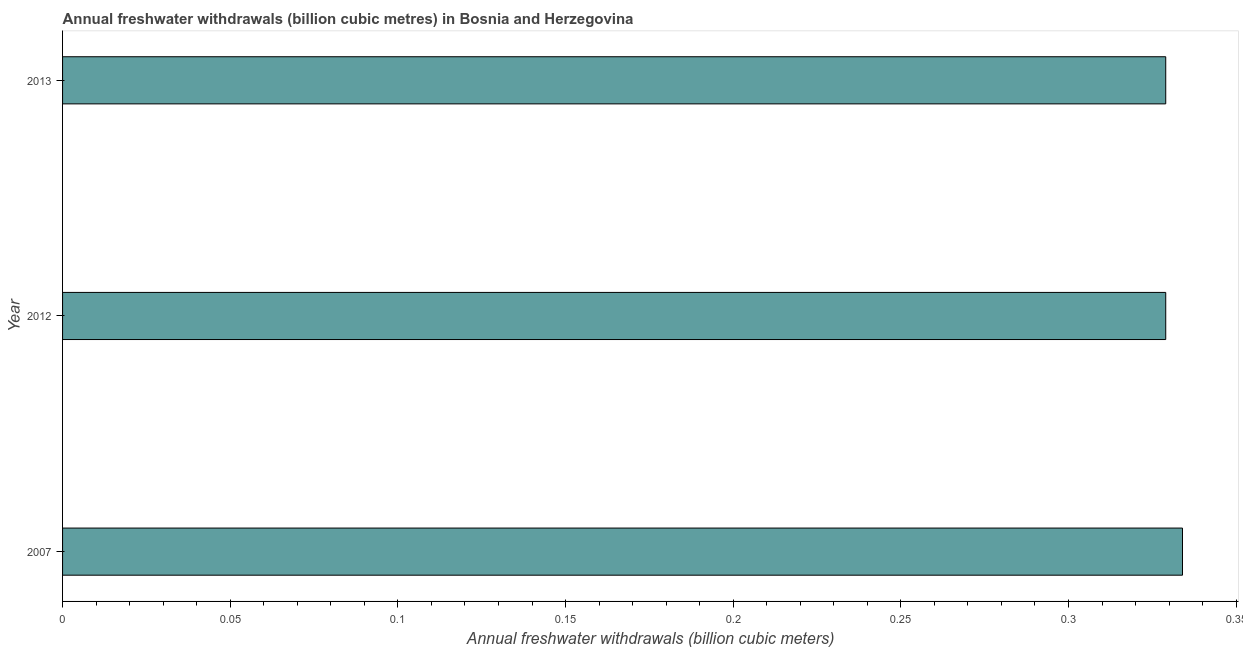What is the title of the graph?
Your answer should be compact. Annual freshwater withdrawals (billion cubic metres) in Bosnia and Herzegovina. What is the label or title of the X-axis?
Provide a short and direct response. Annual freshwater withdrawals (billion cubic meters). What is the annual freshwater withdrawals in 2012?
Your response must be concise. 0.33. Across all years, what is the maximum annual freshwater withdrawals?
Keep it short and to the point. 0.33. Across all years, what is the minimum annual freshwater withdrawals?
Make the answer very short. 0.33. In which year was the annual freshwater withdrawals maximum?
Provide a succinct answer. 2007. In which year was the annual freshwater withdrawals minimum?
Give a very brief answer. 2012. What is the difference between the annual freshwater withdrawals in 2012 and 2013?
Provide a short and direct response. 0. What is the average annual freshwater withdrawals per year?
Your answer should be compact. 0.33. What is the median annual freshwater withdrawals?
Make the answer very short. 0.33. What is the ratio of the annual freshwater withdrawals in 2012 to that in 2013?
Make the answer very short. 1. Is the difference between the annual freshwater withdrawals in 2012 and 2013 greater than the difference between any two years?
Give a very brief answer. No. What is the difference between the highest and the second highest annual freshwater withdrawals?
Make the answer very short. 0.01. How many bars are there?
Your answer should be compact. 3. What is the difference between two consecutive major ticks on the X-axis?
Offer a terse response. 0.05. Are the values on the major ticks of X-axis written in scientific E-notation?
Provide a succinct answer. No. What is the Annual freshwater withdrawals (billion cubic meters) of 2007?
Make the answer very short. 0.33. What is the Annual freshwater withdrawals (billion cubic meters) of 2012?
Your answer should be very brief. 0.33. What is the Annual freshwater withdrawals (billion cubic meters) of 2013?
Make the answer very short. 0.33. What is the difference between the Annual freshwater withdrawals (billion cubic meters) in 2007 and 2012?
Offer a very short reply. 0.01. What is the difference between the Annual freshwater withdrawals (billion cubic meters) in 2007 and 2013?
Your answer should be very brief. 0.01. What is the ratio of the Annual freshwater withdrawals (billion cubic meters) in 2007 to that in 2012?
Make the answer very short. 1.01. What is the ratio of the Annual freshwater withdrawals (billion cubic meters) in 2012 to that in 2013?
Keep it short and to the point. 1. 